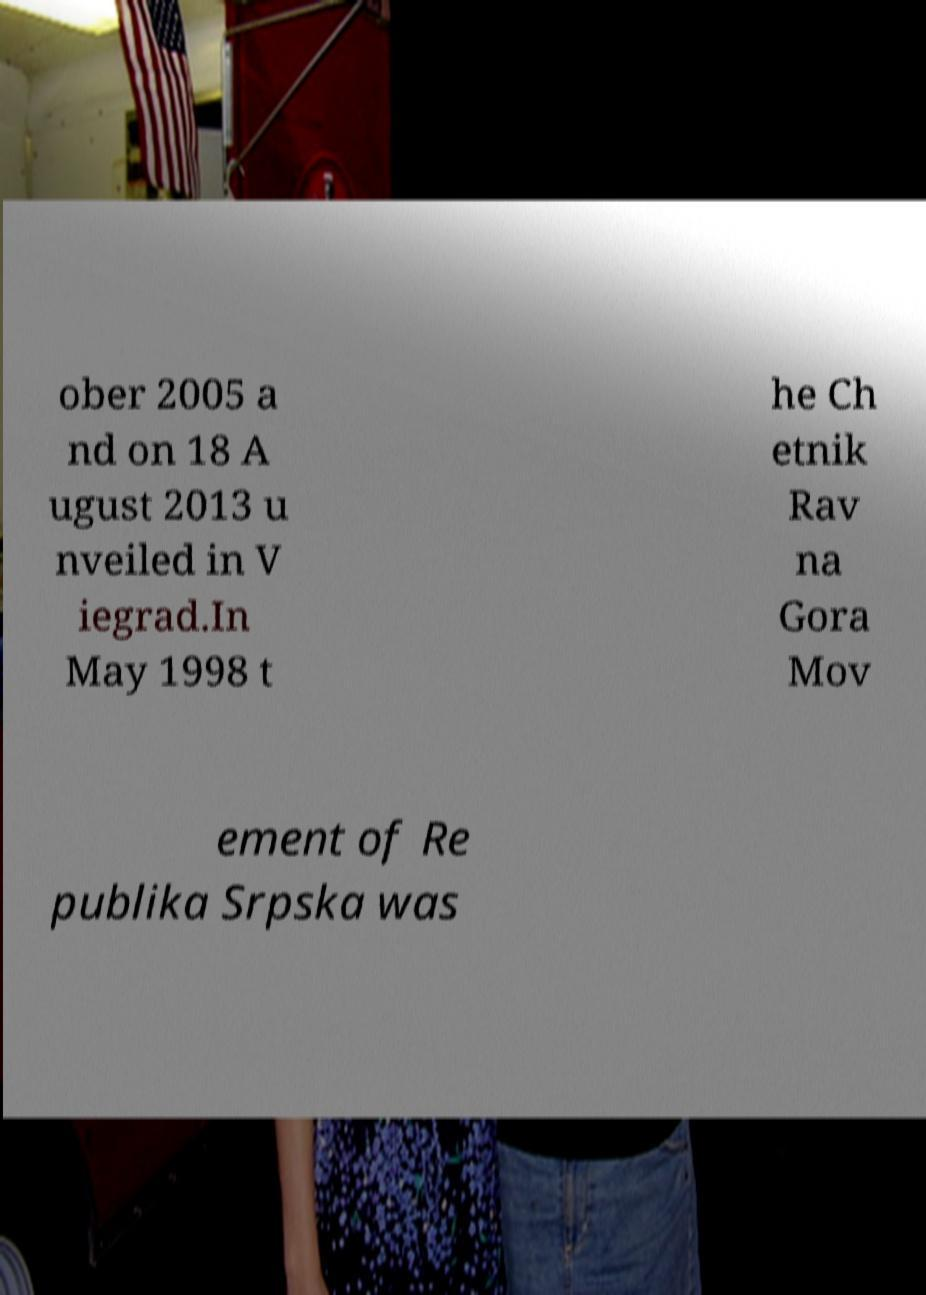Can you read and provide the text displayed in the image?This photo seems to have some interesting text. Can you extract and type it out for me? ober 2005 a nd on 18 A ugust 2013 u nveiled in V iegrad.In May 1998 t he Ch etnik Rav na Gora Mov ement of Re publika Srpska was 